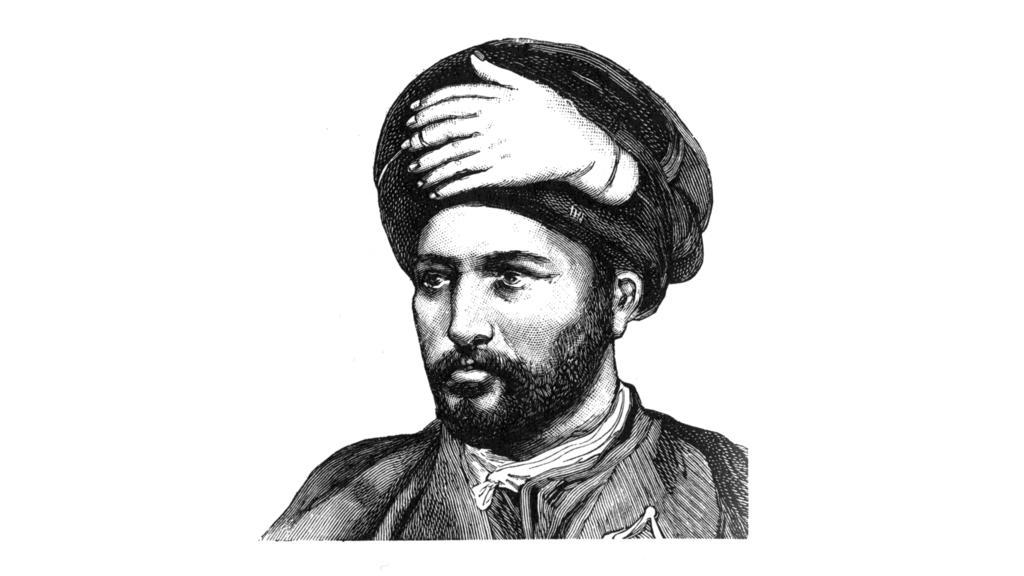How would you summarize this image in a sentence or two? In the picture we can see a picture of a man with a turban on his head. 